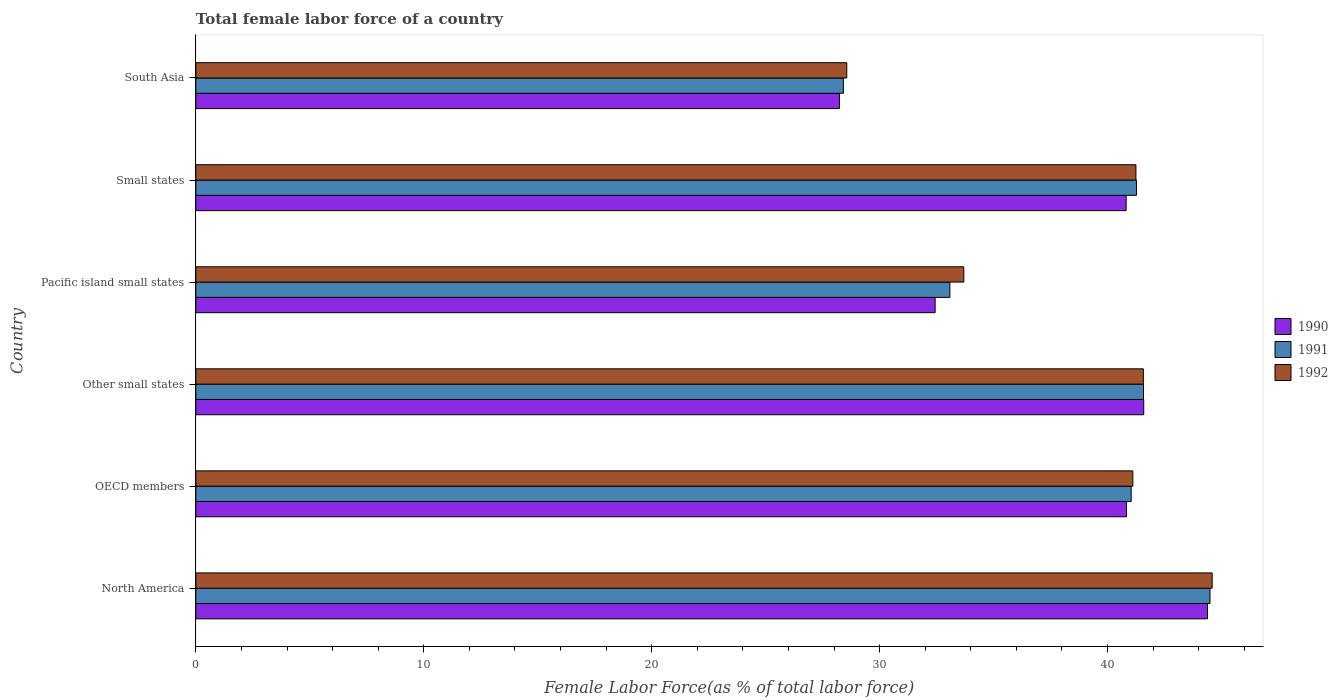How many different coloured bars are there?
Give a very brief answer. 3. How many groups of bars are there?
Offer a very short reply. 6. Are the number of bars on each tick of the Y-axis equal?
Your answer should be very brief. Yes. How many bars are there on the 6th tick from the top?
Ensure brevity in your answer.  3. How many bars are there on the 2nd tick from the bottom?
Give a very brief answer. 3. What is the label of the 2nd group of bars from the top?
Offer a very short reply. Small states. What is the percentage of female labor force in 1992 in North America?
Your answer should be very brief. 44.59. Across all countries, what is the maximum percentage of female labor force in 1990?
Offer a very short reply. 44.39. Across all countries, what is the minimum percentage of female labor force in 1991?
Keep it short and to the point. 28.41. In which country was the percentage of female labor force in 1992 minimum?
Give a very brief answer. South Asia. What is the total percentage of female labor force in 1990 in the graph?
Your response must be concise. 228.29. What is the difference between the percentage of female labor force in 1992 in North America and that in Small states?
Offer a terse response. 3.35. What is the difference between the percentage of female labor force in 1990 in South Asia and the percentage of female labor force in 1992 in Pacific island small states?
Offer a very short reply. -5.46. What is the average percentage of female labor force in 1992 per country?
Give a very brief answer. 38.46. What is the difference between the percentage of female labor force in 1991 and percentage of female labor force in 1990 in Pacific island small states?
Provide a succinct answer. 0.65. What is the ratio of the percentage of female labor force in 1991 in North America to that in Pacific island small states?
Give a very brief answer. 1.34. What is the difference between the highest and the second highest percentage of female labor force in 1991?
Your answer should be very brief. 2.92. What is the difference between the highest and the lowest percentage of female labor force in 1990?
Your answer should be compact. 16.15. In how many countries, is the percentage of female labor force in 1992 greater than the average percentage of female labor force in 1992 taken over all countries?
Provide a short and direct response. 4. What does the 1st bar from the top in Pacific island small states represents?
Offer a terse response. 1992. What does the 3rd bar from the bottom in North America represents?
Offer a terse response. 1992. How many bars are there?
Give a very brief answer. 18. Are all the bars in the graph horizontal?
Ensure brevity in your answer.  Yes. How many countries are there in the graph?
Keep it short and to the point. 6. Are the values on the major ticks of X-axis written in scientific E-notation?
Offer a terse response. No. Does the graph contain any zero values?
Offer a very short reply. No. How many legend labels are there?
Make the answer very short. 3. How are the legend labels stacked?
Ensure brevity in your answer.  Vertical. What is the title of the graph?
Your answer should be compact. Total female labor force of a country. What is the label or title of the X-axis?
Ensure brevity in your answer.  Female Labor Force(as % of total labor force). What is the Female Labor Force(as % of total labor force) of 1990 in North America?
Provide a short and direct response. 44.39. What is the Female Labor Force(as % of total labor force) in 1991 in North America?
Make the answer very short. 44.5. What is the Female Labor Force(as % of total labor force) in 1992 in North America?
Offer a very short reply. 44.59. What is the Female Labor Force(as % of total labor force) of 1990 in OECD members?
Your response must be concise. 40.83. What is the Female Labor Force(as % of total labor force) of 1991 in OECD members?
Provide a succinct answer. 41.04. What is the Female Labor Force(as % of total labor force) of 1992 in OECD members?
Offer a terse response. 41.11. What is the Female Labor Force(as % of total labor force) of 1990 in Other small states?
Make the answer very short. 41.59. What is the Female Labor Force(as % of total labor force) in 1991 in Other small states?
Your response must be concise. 41.58. What is the Female Labor Force(as % of total labor force) in 1992 in Other small states?
Provide a short and direct response. 41.57. What is the Female Labor Force(as % of total labor force) in 1990 in Pacific island small states?
Make the answer very short. 32.44. What is the Female Labor Force(as % of total labor force) of 1991 in Pacific island small states?
Keep it short and to the point. 33.08. What is the Female Labor Force(as % of total labor force) of 1992 in Pacific island small states?
Your answer should be very brief. 33.69. What is the Female Labor Force(as % of total labor force) in 1990 in Small states?
Provide a short and direct response. 40.82. What is the Female Labor Force(as % of total labor force) in 1991 in Small states?
Ensure brevity in your answer.  41.27. What is the Female Labor Force(as % of total labor force) of 1992 in Small states?
Your response must be concise. 41.25. What is the Female Labor Force(as % of total labor force) of 1990 in South Asia?
Offer a very short reply. 28.24. What is the Female Labor Force(as % of total labor force) of 1991 in South Asia?
Ensure brevity in your answer.  28.41. What is the Female Labor Force(as % of total labor force) in 1992 in South Asia?
Keep it short and to the point. 28.56. Across all countries, what is the maximum Female Labor Force(as % of total labor force) in 1990?
Provide a succinct answer. 44.39. Across all countries, what is the maximum Female Labor Force(as % of total labor force) in 1991?
Offer a very short reply. 44.5. Across all countries, what is the maximum Female Labor Force(as % of total labor force) in 1992?
Give a very brief answer. 44.59. Across all countries, what is the minimum Female Labor Force(as % of total labor force) of 1990?
Keep it short and to the point. 28.24. Across all countries, what is the minimum Female Labor Force(as % of total labor force) in 1991?
Offer a very short reply. 28.41. Across all countries, what is the minimum Female Labor Force(as % of total labor force) in 1992?
Ensure brevity in your answer.  28.56. What is the total Female Labor Force(as % of total labor force) in 1990 in the graph?
Keep it short and to the point. 228.29. What is the total Female Labor Force(as % of total labor force) in 1991 in the graph?
Your answer should be very brief. 229.87. What is the total Female Labor Force(as % of total labor force) in 1992 in the graph?
Ensure brevity in your answer.  230.77. What is the difference between the Female Labor Force(as % of total labor force) in 1990 in North America and that in OECD members?
Ensure brevity in your answer.  3.56. What is the difference between the Female Labor Force(as % of total labor force) of 1991 in North America and that in OECD members?
Your answer should be very brief. 3.46. What is the difference between the Female Labor Force(as % of total labor force) in 1992 in North America and that in OECD members?
Provide a short and direct response. 3.48. What is the difference between the Female Labor Force(as % of total labor force) in 1990 in North America and that in Other small states?
Keep it short and to the point. 2.8. What is the difference between the Female Labor Force(as % of total labor force) in 1991 in North America and that in Other small states?
Ensure brevity in your answer.  2.92. What is the difference between the Female Labor Force(as % of total labor force) in 1992 in North America and that in Other small states?
Provide a short and direct response. 3.02. What is the difference between the Female Labor Force(as % of total labor force) of 1990 in North America and that in Pacific island small states?
Make the answer very short. 11.95. What is the difference between the Female Labor Force(as % of total labor force) in 1991 in North America and that in Pacific island small states?
Provide a succinct answer. 11.41. What is the difference between the Female Labor Force(as % of total labor force) in 1992 in North America and that in Pacific island small states?
Make the answer very short. 10.9. What is the difference between the Female Labor Force(as % of total labor force) in 1990 in North America and that in Small states?
Keep it short and to the point. 3.57. What is the difference between the Female Labor Force(as % of total labor force) of 1991 in North America and that in Small states?
Offer a terse response. 3.23. What is the difference between the Female Labor Force(as % of total labor force) of 1992 in North America and that in Small states?
Offer a very short reply. 3.35. What is the difference between the Female Labor Force(as % of total labor force) of 1990 in North America and that in South Asia?
Make the answer very short. 16.15. What is the difference between the Female Labor Force(as % of total labor force) of 1991 in North America and that in South Asia?
Keep it short and to the point. 16.08. What is the difference between the Female Labor Force(as % of total labor force) of 1992 in North America and that in South Asia?
Offer a very short reply. 16.03. What is the difference between the Female Labor Force(as % of total labor force) of 1990 in OECD members and that in Other small states?
Ensure brevity in your answer.  -0.76. What is the difference between the Female Labor Force(as % of total labor force) of 1991 in OECD members and that in Other small states?
Your answer should be compact. -0.54. What is the difference between the Female Labor Force(as % of total labor force) of 1992 in OECD members and that in Other small states?
Provide a short and direct response. -0.46. What is the difference between the Female Labor Force(as % of total labor force) in 1990 in OECD members and that in Pacific island small states?
Give a very brief answer. 8.39. What is the difference between the Female Labor Force(as % of total labor force) in 1991 in OECD members and that in Pacific island small states?
Ensure brevity in your answer.  7.95. What is the difference between the Female Labor Force(as % of total labor force) in 1992 in OECD members and that in Pacific island small states?
Keep it short and to the point. 7.42. What is the difference between the Female Labor Force(as % of total labor force) of 1990 in OECD members and that in Small states?
Your response must be concise. 0.01. What is the difference between the Female Labor Force(as % of total labor force) of 1991 in OECD members and that in Small states?
Your answer should be very brief. -0.23. What is the difference between the Female Labor Force(as % of total labor force) in 1992 in OECD members and that in Small states?
Your response must be concise. -0.13. What is the difference between the Female Labor Force(as % of total labor force) of 1990 in OECD members and that in South Asia?
Provide a short and direct response. 12.59. What is the difference between the Female Labor Force(as % of total labor force) in 1991 in OECD members and that in South Asia?
Ensure brevity in your answer.  12.63. What is the difference between the Female Labor Force(as % of total labor force) in 1992 in OECD members and that in South Asia?
Your answer should be very brief. 12.55. What is the difference between the Female Labor Force(as % of total labor force) in 1990 in Other small states and that in Pacific island small states?
Keep it short and to the point. 9.15. What is the difference between the Female Labor Force(as % of total labor force) of 1991 in Other small states and that in Pacific island small states?
Ensure brevity in your answer.  8.49. What is the difference between the Female Labor Force(as % of total labor force) of 1992 in Other small states and that in Pacific island small states?
Offer a terse response. 7.88. What is the difference between the Female Labor Force(as % of total labor force) in 1990 in Other small states and that in Small states?
Your answer should be compact. 0.77. What is the difference between the Female Labor Force(as % of total labor force) of 1991 in Other small states and that in Small states?
Your answer should be very brief. 0.31. What is the difference between the Female Labor Force(as % of total labor force) in 1992 in Other small states and that in Small states?
Offer a terse response. 0.33. What is the difference between the Female Labor Force(as % of total labor force) of 1990 in Other small states and that in South Asia?
Your response must be concise. 13.35. What is the difference between the Female Labor Force(as % of total labor force) of 1991 in Other small states and that in South Asia?
Your response must be concise. 13.17. What is the difference between the Female Labor Force(as % of total labor force) of 1992 in Other small states and that in South Asia?
Offer a very short reply. 13.01. What is the difference between the Female Labor Force(as % of total labor force) of 1990 in Pacific island small states and that in Small states?
Your response must be concise. -8.38. What is the difference between the Female Labor Force(as % of total labor force) of 1991 in Pacific island small states and that in Small states?
Offer a very short reply. -8.19. What is the difference between the Female Labor Force(as % of total labor force) in 1992 in Pacific island small states and that in Small states?
Your answer should be compact. -7.55. What is the difference between the Female Labor Force(as % of total labor force) of 1990 in Pacific island small states and that in South Asia?
Your answer should be very brief. 4.2. What is the difference between the Female Labor Force(as % of total labor force) in 1991 in Pacific island small states and that in South Asia?
Give a very brief answer. 4.67. What is the difference between the Female Labor Force(as % of total labor force) of 1992 in Pacific island small states and that in South Asia?
Ensure brevity in your answer.  5.13. What is the difference between the Female Labor Force(as % of total labor force) of 1990 in Small states and that in South Asia?
Offer a very short reply. 12.58. What is the difference between the Female Labor Force(as % of total labor force) in 1991 in Small states and that in South Asia?
Provide a short and direct response. 12.86. What is the difference between the Female Labor Force(as % of total labor force) of 1992 in Small states and that in South Asia?
Provide a succinct answer. 12.69. What is the difference between the Female Labor Force(as % of total labor force) of 1990 in North America and the Female Labor Force(as % of total labor force) of 1991 in OECD members?
Your answer should be very brief. 3.35. What is the difference between the Female Labor Force(as % of total labor force) in 1990 in North America and the Female Labor Force(as % of total labor force) in 1992 in OECD members?
Your answer should be compact. 3.27. What is the difference between the Female Labor Force(as % of total labor force) in 1991 in North America and the Female Labor Force(as % of total labor force) in 1992 in OECD members?
Give a very brief answer. 3.38. What is the difference between the Female Labor Force(as % of total labor force) of 1990 in North America and the Female Labor Force(as % of total labor force) of 1991 in Other small states?
Make the answer very short. 2.81. What is the difference between the Female Labor Force(as % of total labor force) of 1990 in North America and the Female Labor Force(as % of total labor force) of 1992 in Other small states?
Your answer should be compact. 2.81. What is the difference between the Female Labor Force(as % of total labor force) of 1991 in North America and the Female Labor Force(as % of total labor force) of 1992 in Other small states?
Give a very brief answer. 2.92. What is the difference between the Female Labor Force(as % of total labor force) of 1990 in North America and the Female Labor Force(as % of total labor force) of 1991 in Pacific island small states?
Provide a succinct answer. 11.3. What is the difference between the Female Labor Force(as % of total labor force) in 1990 in North America and the Female Labor Force(as % of total labor force) in 1992 in Pacific island small states?
Make the answer very short. 10.69. What is the difference between the Female Labor Force(as % of total labor force) in 1991 in North America and the Female Labor Force(as % of total labor force) in 1992 in Pacific island small states?
Offer a very short reply. 10.8. What is the difference between the Female Labor Force(as % of total labor force) in 1990 in North America and the Female Labor Force(as % of total labor force) in 1991 in Small states?
Keep it short and to the point. 3.12. What is the difference between the Female Labor Force(as % of total labor force) in 1990 in North America and the Female Labor Force(as % of total labor force) in 1992 in Small states?
Your answer should be compact. 3.14. What is the difference between the Female Labor Force(as % of total labor force) in 1991 in North America and the Female Labor Force(as % of total labor force) in 1992 in Small states?
Offer a terse response. 3.25. What is the difference between the Female Labor Force(as % of total labor force) of 1990 in North America and the Female Labor Force(as % of total labor force) of 1991 in South Asia?
Your answer should be very brief. 15.97. What is the difference between the Female Labor Force(as % of total labor force) of 1990 in North America and the Female Labor Force(as % of total labor force) of 1992 in South Asia?
Make the answer very short. 15.83. What is the difference between the Female Labor Force(as % of total labor force) in 1991 in North America and the Female Labor Force(as % of total labor force) in 1992 in South Asia?
Offer a very short reply. 15.94. What is the difference between the Female Labor Force(as % of total labor force) in 1990 in OECD members and the Female Labor Force(as % of total labor force) in 1991 in Other small states?
Your response must be concise. -0.75. What is the difference between the Female Labor Force(as % of total labor force) in 1990 in OECD members and the Female Labor Force(as % of total labor force) in 1992 in Other small states?
Your answer should be very brief. -0.74. What is the difference between the Female Labor Force(as % of total labor force) in 1991 in OECD members and the Female Labor Force(as % of total labor force) in 1992 in Other small states?
Provide a succinct answer. -0.53. What is the difference between the Female Labor Force(as % of total labor force) in 1990 in OECD members and the Female Labor Force(as % of total labor force) in 1991 in Pacific island small states?
Offer a terse response. 7.75. What is the difference between the Female Labor Force(as % of total labor force) in 1990 in OECD members and the Female Labor Force(as % of total labor force) in 1992 in Pacific island small states?
Offer a terse response. 7.14. What is the difference between the Female Labor Force(as % of total labor force) of 1991 in OECD members and the Female Labor Force(as % of total labor force) of 1992 in Pacific island small states?
Your answer should be very brief. 7.34. What is the difference between the Female Labor Force(as % of total labor force) in 1990 in OECD members and the Female Labor Force(as % of total labor force) in 1991 in Small states?
Offer a terse response. -0.44. What is the difference between the Female Labor Force(as % of total labor force) of 1990 in OECD members and the Female Labor Force(as % of total labor force) of 1992 in Small states?
Your response must be concise. -0.42. What is the difference between the Female Labor Force(as % of total labor force) of 1991 in OECD members and the Female Labor Force(as % of total labor force) of 1992 in Small states?
Make the answer very short. -0.21. What is the difference between the Female Labor Force(as % of total labor force) of 1990 in OECD members and the Female Labor Force(as % of total labor force) of 1991 in South Asia?
Make the answer very short. 12.42. What is the difference between the Female Labor Force(as % of total labor force) in 1990 in OECD members and the Female Labor Force(as % of total labor force) in 1992 in South Asia?
Provide a succinct answer. 12.27. What is the difference between the Female Labor Force(as % of total labor force) of 1991 in OECD members and the Female Labor Force(as % of total labor force) of 1992 in South Asia?
Offer a very short reply. 12.48. What is the difference between the Female Labor Force(as % of total labor force) of 1990 in Other small states and the Female Labor Force(as % of total labor force) of 1991 in Pacific island small states?
Provide a short and direct response. 8.5. What is the difference between the Female Labor Force(as % of total labor force) of 1990 in Other small states and the Female Labor Force(as % of total labor force) of 1992 in Pacific island small states?
Your answer should be compact. 7.89. What is the difference between the Female Labor Force(as % of total labor force) of 1991 in Other small states and the Female Labor Force(as % of total labor force) of 1992 in Pacific island small states?
Ensure brevity in your answer.  7.88. What is the difference between the Female Labor Force(as % of total labor force) in 1990 in Other small states and the Female Labor Force(as % of total labor force) in 1991 in Small states?
Your answer should be compact. 0.32. What is the difference between the Female Labor Force(as % of total labor force) in 1990 in Other small states and the Female Labor Force(as % of total labor force) in 1992 in Small states?
Give a very brief answer. 0.34. What is the difference between the Female Labor Force(as % of total labor force) in 1991 in Other small states and the Female Labor Force(as % of total labor force) in 1992 in Small states?
Give a very brief answer. 0.33. What is the difference between the Female Labor Force(as % of total labor force) in 1990 in Other small states and the Female Labor Force(as % of total labor force) in 1991 in South Asia?
Provide a succinct answer. 13.18. What is the difference between the Female Labor Force(as % of total labor force) in 1990 in Other small states and the Female Labor Force(as % of total labor force) in 1992 in South Asia?
Make the answer very short. 13.03. What is the difference between the Female Labor Force(as % of total labor force) in 1991 in Other small states and the Female Labor Force(as % of total labor force) in 1992 in South Asia?
Your answer should be very brief. 13.02. What is the difference between the Female Labor Force(as % of total labor force) of 1990 in Pacific island small states and the Female Labor Force(as % of total labor force) of 1991 in Small states?
Give a very brief answer. -8.83. What is the difference between the Female Labor Force(as % of total labor force) of 1990 in Pacific island small states and the Female Labor Force(as % of total labor force) of 1992 in Small states?
Provide a short and direct response. -8.81. What is the difference between the Female Labor Force(as % of total labor force) of 1991 in Pacific island small states and the Female Labor Force(as % of total labor force) of 1992 in Small states?
Make the answer very short. -8.16. What is the difference between the Female Labor Force(as % of total labor force) of 1990 in Pacific island small states and the Female Labor Force(as % of total labor force) of 1991 in South Asia?
Make the answer very short. 4.03. What is the difference between the Female Labor Force(as % of total labor force) in 1990 in Pacific island small states and the Female Labor Force(as % of total labor force) in 1992 in South Asia?
Offer a very short reply. 3.88. What is the difference between the Female Labor Force(as % of total labor force) in 1991 in Pacific island small states and the Female Labor Force(as % of total labor force) in 1992 in South Asia?
Keep it short and to the point. 4.52. What is the difference between the Female Labor Force(as % of total labor force) of 1990 in Small states and the Female Labor Force(as % of total labor force) of 1991 in South Asia?
Give a very brief answer. 12.41. What is the difference between the Female Labor Force(as % of total labor force) in 1990 in Small states and the Female Labor Force(as % of total labor force) in 1992 in South Asia?
Provide a short and direct response. 12.26. What is the difference between the Female Labor Force(as % of total labor force) in 1991 in Small states and the Female Labor Force(as % of total labor force) in 1992 in South Asia?
Offer a very short reply. 12.71. What is the average Female Labor Force(as % of total labor force) of 1990 per country?
Keep it short and to the point. 38.05. What is the average Female Labor Force(as % of total labor force) of 1991 per country?
Provide a short and direct response. 38.31. What is the average Female Labor Force(as % of total labor force) in 1992 per country?
Provide a short and direct response. 38.46. What is the difference between the Female Labor Force(as % of total labor force) of 1990 and Female Labor Force(as % of total labor force) of 1991 in North America?
Your response must be concise. -0.11. What is the difference between the Female Labor Force(as % of total labor force) of 1990 and Female Labor Force(as % of total labor force) of 1992 in North America?
Give a very brief answer. -0.21. What is the difference between the Female Labor Force(as % of total labor force) of 1991 and Female Labor Force(as % of total labor force) of 1992 in North America?
Your response must be concise. -0.1. What is the difference between the Female Labor Force(as % of total labor force) of 1990 and Female Labor Force(as % of total labor force) of 1991 in OECD members?
Your answer should be compact. -0.21. What is the difference between the Female Labor Force(as % of total labor force) in 1990 and Female Labor Force(as % of total labor force) in 1992 in OECD members?
Your answer should be very brief. -0.28. What is the difference between the Female Labor Force(as % of total labor force) of 1991 and Female Labor Force(as % of total labor force) of 1992 in OECD members?
Provide a short and direct response. -0.07. What is the difference between the Female Labor Force(as % of total labor force) of 1990 and Female Labor Force(as % of total labor force) of 1991 in Other small states?
Give a very brief answer. 0.01. What is the difference between the Female Labor Force(as % of total labor force) of 1990 and Female Labor Force(as % of total labor force) of 1992 in Other small states?
Offer a terse response. 0.02. What is the difference between the Female Labor Force(as % of total labor force) of 1991 and Female Labor Force(as % of total labor force) of 1992 in Other small states?
Provide a short and direct response. 0. What is the difference between the Female Labor Force(as % of total labor force) of 1990 and Female Labor Force(as % of total labor force) of 1991 in Pacific island small states?
Your answer should be compact. -0.65. What is the difference between the Female Labor Force(as % of total labor force) in 1990 and Female Labor Force(as % of total labor force) in 1992 in Pacific island small states?
Keep it short and to the point. -1.26. What is the difference between the Female Labor Force(as % of total labor force) of 1991 and Female Labor Force(as % of total labor force) of 1992 in Pacific island small states?
Provide a short and direct response. -0.61. What is the difference between the Female Labor Force(as % of total labor force) in 1990 and Female Labor Force(as % of total labor force) in 1991 in Small states?
Give a very brief answer. -0.45. What is the difference between the Female Labor Force(as % of total labor force) of 1990 and Female Labor Force(as % of total labor force) of 1992 in Small states?
Ensure brevity in your answer.  -0.43. What is the difference between the Female Labor Force(as % of total labor force) of 1991 and Female Labor Force(as % of total labor force) of 1992 in Small states?
Give a very brief answer. 0.02. What is the difference between the Female Labor Force(as % of total labor force) in 1990 and Female Labor Force(as % of total labor force) in 1991 in South Asia?
Your response must be concise. -0.17. What is the difference between the Female Labor Force(as % of total labor force) in 1990 and Female Labor Force(as % of total labor force) in 1992 in South Asia?
Make the answer very short. -0.32. What is the difference between the Female Labor Force(as % of total labor force) of 1991 and Female Labor Force(as % of total labor force) of 1992 in South Asia?
Provide a succinct answer. -0.15. What is the ratio of the Female Labor Force(as % of total labor force) in 1990 in North America to that in OECD members?
Your response must be concise. 1.09. What is the ratio of the Female Labor Force(as % of total labor force) in 1991 in North America to that in OECD members?
Your answer should be compact. 1.08. What is the ratio of the Female Labor Force(as % of total labor force) in 1992 in North America to that in OECD members?
Offer a very short reply. 1.08. What is the ratio of the Female Labor Force(as % of total labor force) of 1990 in North America to that in Other small states?
Keep it short and to the point. 1.07. What is the ratio of the Female Labor Force(as % of total labor force) in 1991 in North America to that in Other small states?
Make the answer very short. 1.07. What is the ratio of the Female Labor Force(as % of total labor force) in 1992 in North America to that in Other small states?
Ensure brevity in your answer.  1.07. What is the ratio of the Female Labor Force(as % of total labor force) of 1990 in North America to that in Pacific island small states?
Provide a succinct answer. 1.37. What is the ratio of the Female Labor Force(as % of total labor force) in 1991 in North America to that in Pacific island small states?
Provide a short and direct response. 1.34. What is the ratio of the Female Labor Force(as % of total labor force) of 1992 in North America to that in Pacific island small states?
Provide a short and direct response. 1.32. What is the ratio of the Female Labor Force(as % of total labor force) of 1990 in North America to that in Small states?
Make the answer very short. 1.09. What is the ratio of the Female Labor Force(as % of total labor force) of 1991 in North America to that in Small states?
Keep it short and to the point. 1.08. What is the ratio of the Female Labor Force(as % of total labor force) of 1992 in North America to that in Small states?
Offer a very short reply. 1.08. What is the ratio of the Female Labor Force(as % of total labor force) of 1990 in North America to that in South Asia?
Your answer should be very brief. 1.57. What is the ratio of the Female Labor Force(as % of total labor force) of 1991 in North America to that in South Asia?
Your answer should be very brief. 1.57. What is the ratio of the Female Labor Force(as % of total labor force) in 1992 in North America to that in South Asia?
Make the answer very short. 1.56. What is the ratio of the Female Labor Force(as % of total labor force) in 1990 in OECD members to that in Other small states?
Give a very brief answer. 0.98. What is the ratio of the Female Labor Force(as % of total labor force) in 1991 in OECD members to that in Other small states?
Offer a very short reply. 0.99. What is the ratio of the Female Labor Force(as % of total labor force) of 1992 in OECD members to that in Other small states?
Offer a terse response. 0.99. What is the ratio of the Female Labor Force(as % of total labor force) of 1990 in OECD members to that in Pacific island small states?
Your response must be concise. 1.26. What is the ratio of the Female Labor Force(as % of total labor force) of 1991 in OECD members to that in Pacific island small states?
Ensure brevity in your answer.  1.24. What is the ratio of the Female Labor Force(as % of total labor force) in 1992 in OECD members to that in Pacific island small states?
Ensure brevity in your answer.  1.22. What is the ratio of the Female Labor Force(as % of total labor force) of 1990 in OECD members to that in Small states?
Offer a very short reply. 1. What is the ratio of the Female Labor Force(as % of total labor force) in 1990 in OECD members to that in South Asia?
Make the answer very short. 1.45. What is the ratio of the Female Labor Force(as % of total labor force) of 1991 in OECD members to that in South Asia?
Offer a terse response. 1.44. What is the ratio of the Female Labor Force(as % of total labor force) in 1992 in OECD members to that in South Asia?
Your response must be concise. 1.44. What is the ratio of the Female Labor Force(as % of total labor force) in 1990 in Other small states to that in Pacific island small states?
Your answer should be very brief. 1.28. What is the ratio of the Female Labor Force(as % of total labor force) of 1991 in Other small states to that in Pacific island small states?
Offer a very short reply. 1.26. What is the ratio of the Female Labor Force(as % of total labor force) of 1992 in Other small states to that in Pacific island small states?
Give a very brief answer. 1.23. What is the ratio of the Female Labor Force(as % of total labor force) of 1990 in Other small states to that in Small states?
Make the answer very short. 1.02. What is the ratio of the Female Labor Force(as % of total labor force) of 1991 in Other small states to that in Small states?
Offer a terse response. 1.01. What is the ratio of the Female Labor Force(as % of total labor force) of 1992 in Other small states to that in Small states?
Ensure brevity in your answer.  1.01. What is the ratio of the Female Labor Force(as % of total labor force) of 1990 in Other small states to that in South Asia?
Provide a succinct answer. 1.47. What is the ratio of the Female Labor Force(as % of total labor force) in 1991 in Other small states to that in South Asia?
Offer a terse response. 1.46. What is the ratio of the Female Labor Force(as % of total labor force) of 1992 in Other small states to that in South Asia?
Your response must be concise. 1.46. What is the ratio of the Female Labor Force(as % of total labor force) of 1990 in Pacific island small states to that in Small states?
Your response must be concise. 0.79. What is the ratio of the Female Labor Force(as % of total labor force) in 1991 in Pacific island small states to that in Small states?
Make the answer very short. 0.8. What is the ratio of the Female Labor Force(as % of total labor force) in 1992 in Pacific island small states to that in Small states?
Make the answer very short. 0.82. What is the ratio of the Female Labor Force(as % of total labor force) in 1990 in Pacific island small states to that in South Asia?
Keep it short and to the point. 1.15. What is the ratio of the Female Labor Force(as % of total labor force) of 1991 in Pacific island small states to that in South Asia?
Provide a short and direct response. 1.16. What is the ratio of the Female Labor Force(as % of total labor force) of 1992 in Pacific island small states to that in South Asia?
Your answer should be compact. 1.18. What is the ratio of the Female Labor Force(as % of total labor force) of 1990 in Small states to that in South Asia?
Make the answer very short. 1.45. What is the ratio of the Female Labor Force(as % of total labor force) of 1991 in Small states to that in South Asia?
Your response must be concise. 1.45. What is the ratio of the Female Labor Force(as % of total labor force) in 1992 in Small states to that in South Asia?
Provide a short and direct response. 1.44. What is the difference between the highest and the second highest Female Labor Force(as % of total labor force) of 1990?
Ensure brevity in your answer.  2.8. What is the difference between the highest and the second highest Female Labor Force(as % of total labor force) of 1991?
Ensure brevity in your answer.  2.92. What is the difference between the highest and the second highest Female Labor Force(as % of total labor force) of 1992?
Your response must be concise. 3.02. What is the difference between the highest and the lowest Female Labor Force(as % of total labor force) in 1990?
Provide a short and direct response. 16.15. What is the difference between the highest and the lowest Female Labor Force(as % of total labor force) of 1991?
Offer a terse response. 16.08. What is the difference between the highest and the lowest Female Labor Force(as % of total labor force) in 1992?
Give a very brief answer. 16.03. 